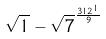Convert formula to latex. <formula><loc_0><loc_0><loc_500><loc_500>\sqrt { 1 } - \sqrt { 7 } ^ { \frac { 3 1 2 ^ { 1 } } { 9 } }</formula> 